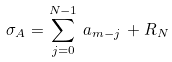Convert formula to latex. <formula><loc_0><loc_0><loc_500><loc_500>\sigma _ { A } = \sum _ { j = 0 } ^ { N - 1 } \, a _ { m - j } \, + R _ { N }</formula> 